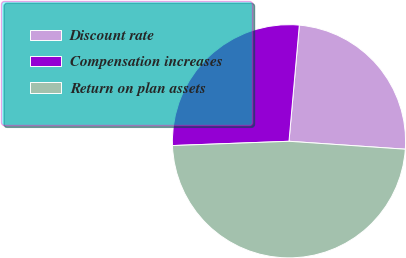Convert chart to OTSL. <chart><loc_0><loc_0><loc_500><loc_500><pie_chart><fcel>Discount rate<fcel>Compensation increases<fcel>Return on plan assets<nl><fcel>24.67%<fcel>27.0%<fcel>48.33%<nl></chart> 